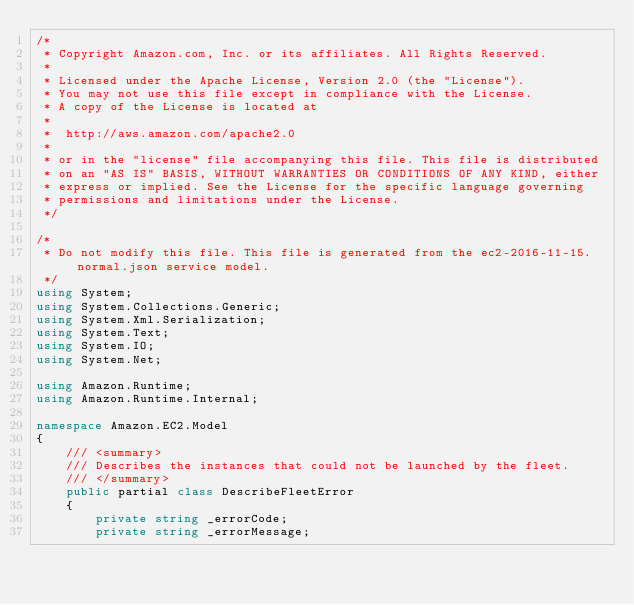<code> <loc_0><loc_0><loc_500><loc_500><_C#_>/*
 * Copyright Amazon.com, Inc. or its affiliates. All Rights Reserved.
 * 
 * Licensed under the Apache License, Version 2.0 (the "License").
 * You may not use this file except in compliance with the License.
 * A copy of the License is located at
 * 
 *  http://aws.amazon.com/apache2.0
 * 
 * or in the "license" file accompanying this file. This file is distributed
 * on an "AS IS" BASIS, WITHOUT WARRANTIES OR CONDITIONS OF ANY KIND, either
 * express or implied. See the License for the specific language governing
 * permissions and limitations under the License.
 */

/*
 * Do not modify this file. This file is generated from the ec2-2016-11-15.normal.json service model.
 */
using System;
using System.Collections.Generic;
using System.Xml.Serialization;
using System.Text;
using System.IO;
using System.Net;

using Amazon.Runtime;
using Amazon.Runtime.Internal;

namespace Amazon.EC2.Model
{
    /// <summary>
    /// Describes the instances that could not be launched by the fleet.
    /// </summary>
    public partial class DescribeFleetError
    {
        private string _errorCode;
        private string _errorMessage;</code> 